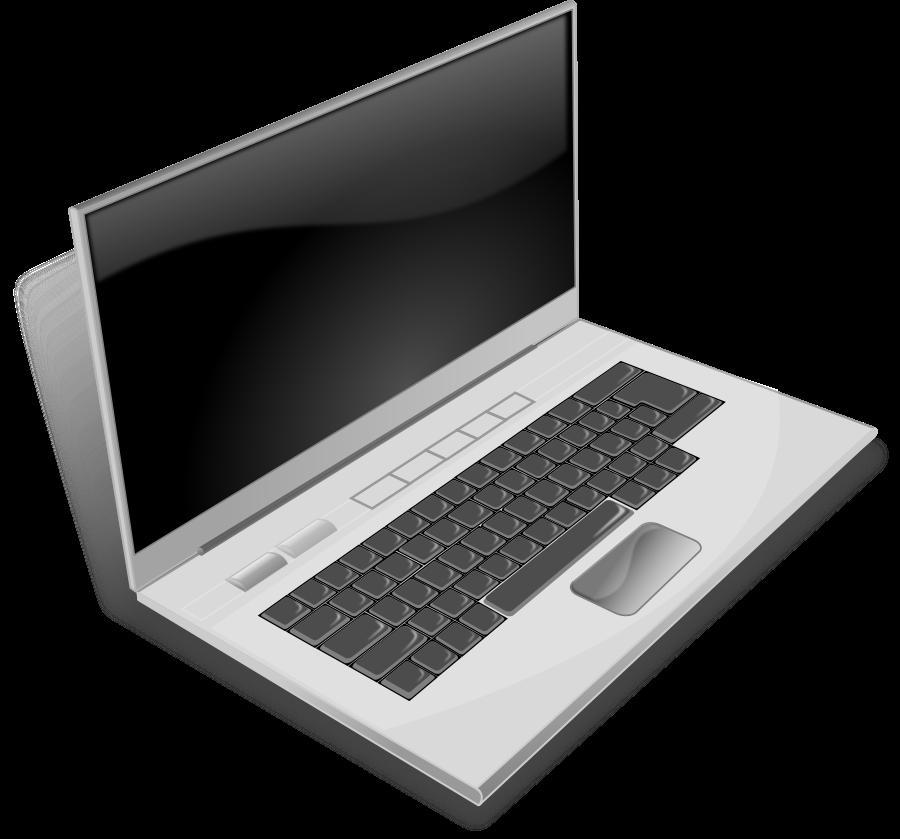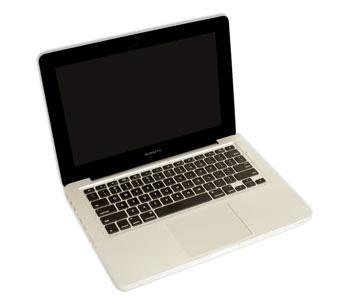The first image is the image on the left, the second image is the image on the right. Examine the images to the left and right. Is the description "A laptop is shown with black background in one of the images." accurate? Answer yes or no. Yes. 